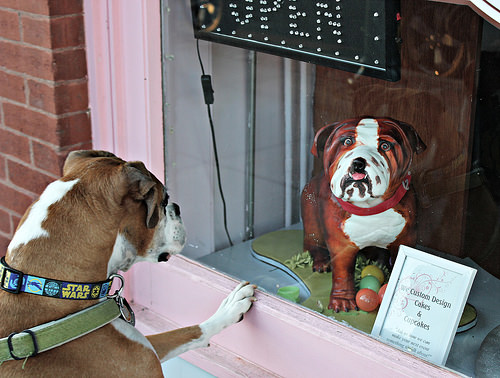<image>
Is the dog behind the glass? Yes. From this viewpoint, the dog is positioned behind the glass, with the glass partially or fully occluding the dog. 